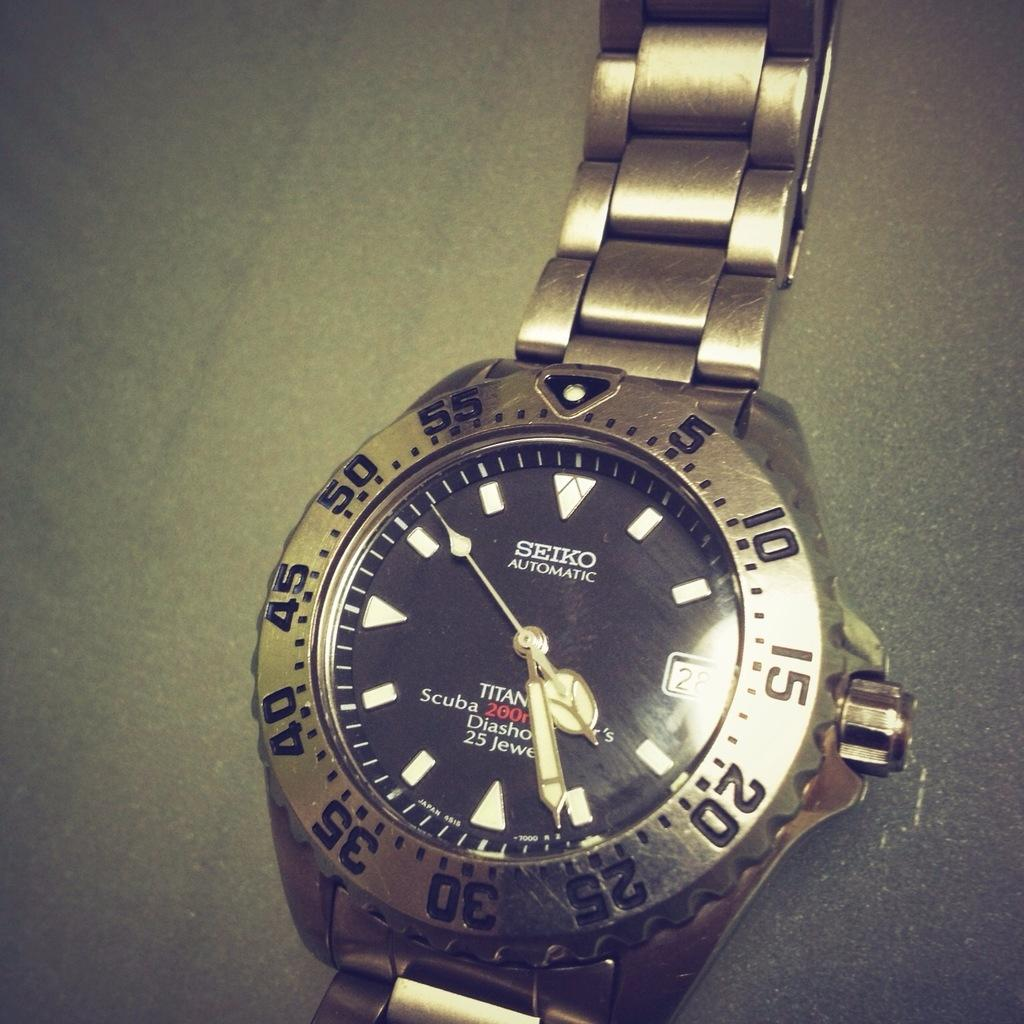<image>
Relay a brief, clear account of the picture shown. A Siko automatic watch shows the time as 4:26. 